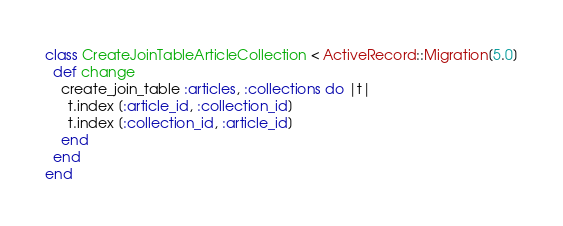<code> <loc_0><loc_0><loc_500><loc_500><_Ruby_>class CreateJoinTableArticleCollection < ActiveRecord::Migration[5.0]
  def change
    create_join_table :articles, :collections do |t|
      t.index [:article_id, :collection_id]
      t.index [:collection_id, :article_id]
    end
  end
end
</code> 